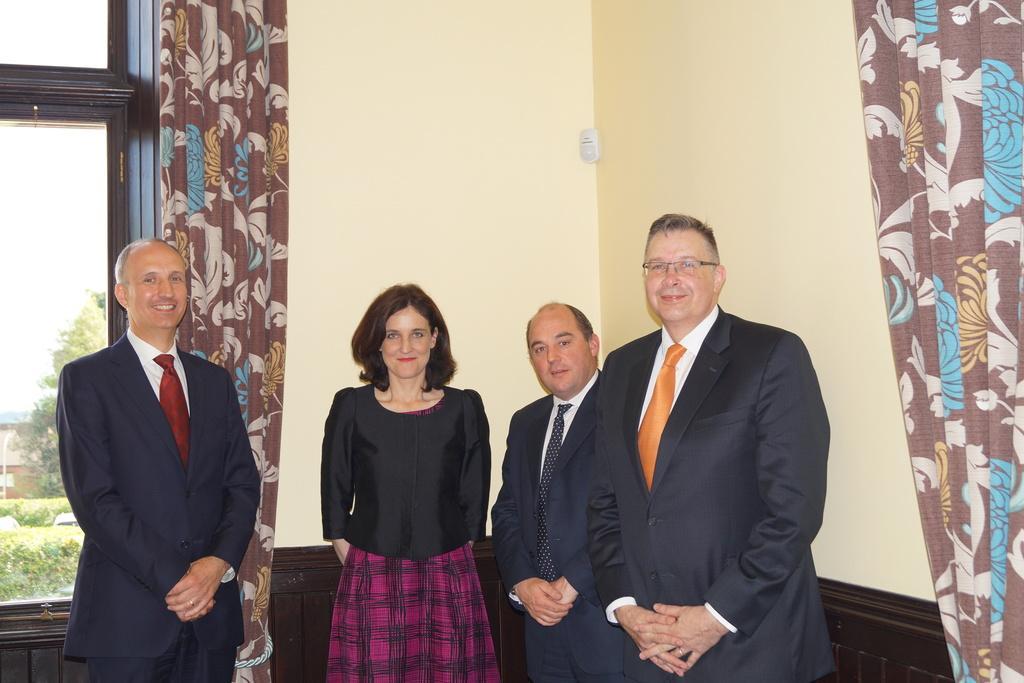Please provide a concise description of this image. In this image in front there are four people wearing a smile on their faces. Behind them there is a wall. There are curtains. There is a glass window through which we can see trees, buildings and sky. 